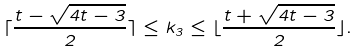<formula> <loc_0><loc_0><loc_500><loc_500>\lceil \frac { t - \sqrt { 4 t - 3 } } { 2 } \rceil \leq k _ { 3 } \leq \lfloor \frac { t + \sqrt { 4 t - 3 } } { 2 } \rfloor .</formula> 